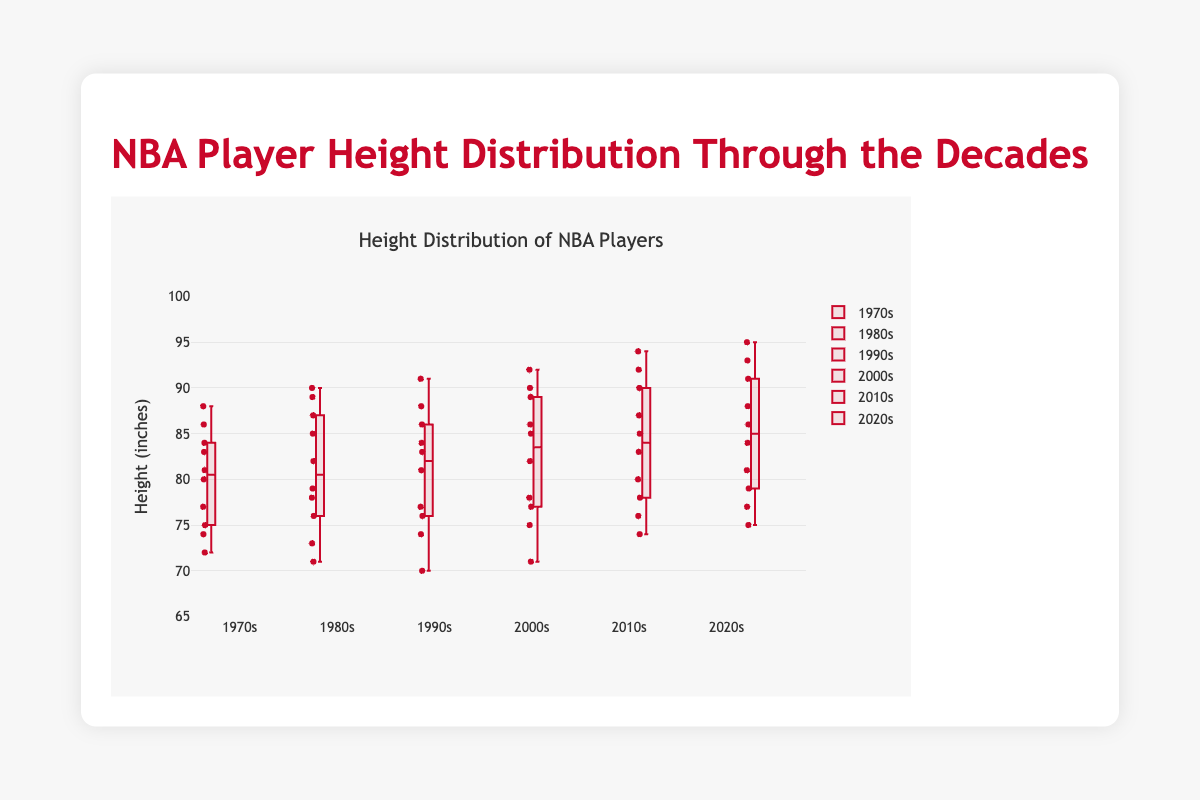What is the median height of NBA players in the 1970s? To find the median height for the 1970s, locate the middle value(s) of the sorted data. For the 1970s, the sorted data is [72, 74, 75, 77, 80, 81, 83, 84, 86, 88]. The middle values are 80 and 81, so the median is the average: (80 + 81)/2 = 80.5 inches.
Answer: 80.5 inches Which decade has the tallest median height? From the box plot, compare the median lines (middle of the boxes) for each decade. The decade with the tallest median height is the 2020s, with a median of 86 inches.
Answer: 2020s How does the interquartile range (IQR) of the 2000s compare to the 1980s? The IQR is the difference between the third quartile (Q3) and the first quartile (Q1). Identify Q3 and Q1 on the box plot for each decade. For the 2000s, Q3 is 90 and Q1 is 77, so IQR = 90 - 77 = 13. For the 1980s, Q3 is 87 and Q1 is 73, so IQR = 87 - 73 = 14.
Answer: The IQR of the 2000s is 13, which is slightly smaller than the IQR of the 1980s, which is 14 In which decade is the range of player heights the largest? The range is the difference between the maximum and minimum values. Check the ends of the whiskers for each decade. For the 2020s, the range is 95 - 75 = 20 inches. This is the largest range among the decades.
Answer: 2020s Which decade shows the smallest spread of player heights? The spread can be judged by looking at the overall length of the box and whiskers. In the 1990s, the spread is smaller because the box and whiskers are more compact, indicating less variability in heights.
Answer: 1990s What is the highest recorded height in the 2010s? Look at the top whisker for the 2010s box; the highest recorded height is 94 inches.
Answer: 94 inches Compare the lower quartile heights of the 1970s and 2010s. Which is higher? The lower quartile (Q1) is the bottom of the box. For the 1970s, Q1 is 75, and for the 2010s, Q1 is 78. The 2010s have a higher lower quartile height.
Answer: 2010s What decade has the most symmetric height distribution? Symmetric distributions have the median line (inside the box) relatively centered between Q1 and Q3. The 1980s have a more symmetric distribution as the median appears close to the center of the box.
Answer: 1980s Estimate the median height during the 2000s. Locate the median line within the box for the 2000s. The median appears around 84 inches.
Answer: 84 inches 